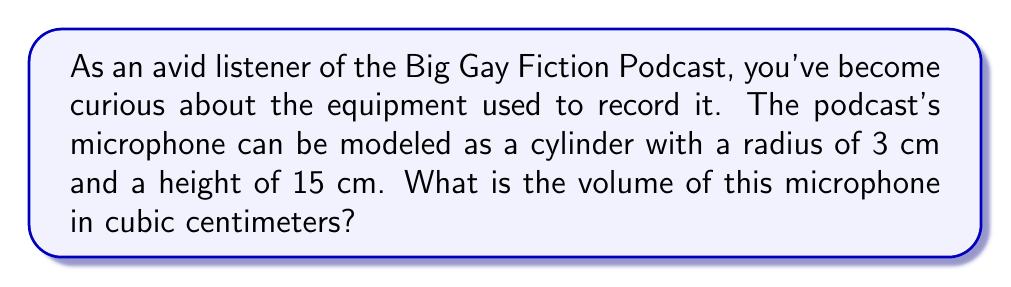Help me with this question. To solve this problem, we'll use the formula for the volume of a cylinder:

$$V = \pi r^2 h$$

Where:
$V$ = volume
$r$ = radius of the base
$h$ = height of the cylinder

Given:
$r = 3$ cm
$h = 15$ cm

Let's substitute these values into the formula:

$$V = \pi (3 \text{ cm})^2 (15 \text{ cm})$$

Simplify:
$$V = \pi (9 \text{ cm}^2) (15 \text{ cm})$$
$$V = 135\pi \text{ cm}^3$$

Calculate the final value (rounded to two decimal places):
$$V \approx 423.90 \text{ cm}^3$$

Therefore, the volume of the podcast microphone modeled as a cylinder is approximately 423.90 cubic centimeters.
Answer: $423.90 \text{ cm}^3$ 